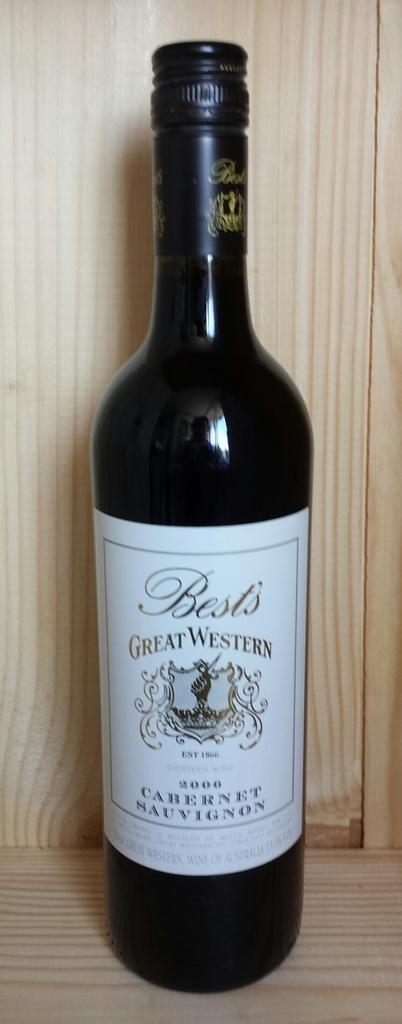Was this wine made in 2006?
Your response must be concise. Yes. 